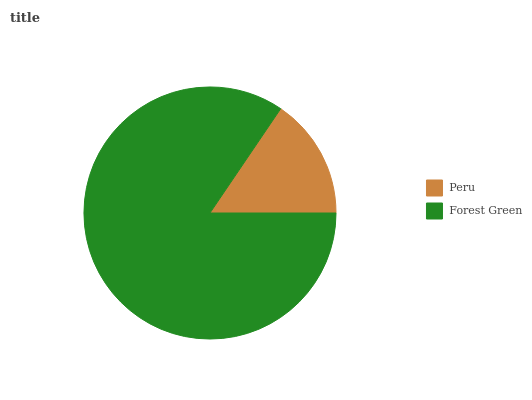Is Peru the minimum?
Answer yes or no. Yes. Is Forest Green the maximum?
Answer yes or no. Yes. Is Forest Green the minimum?
Answer yes or no. No. Is Forest Green greater than Peru?
Answer yes or no. Yes. Is Peru less than Forest Green?
Answer yes or no. Yes. Is Peru greater than Forest Green?
Answer yes or no. No. Is Forest Green less than Peru?
Answer yes or no. No. Is Forest Green the high median?
Answer yes or no. Yes. Is Peru the low median?
Answer yes or no. Yes. Is Peru the high median?
Answer yes or no. No. Is Forest Green the low median?
Answer yes or no. No. 